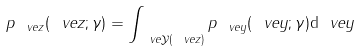Convert formula to latex. <formula><loc_0><loc_0><loc_500><loc_500>p _ { \ v e { z } } ( \ v e { z } ; \gamma ) = \int _ { \ v e { \mathcal { Y } } ( \ v e { z } ) } p _ { \ v e { y } } ( \ v e { y } ; \gamma ) { \mathrm d } \ v e { y }</formula> 